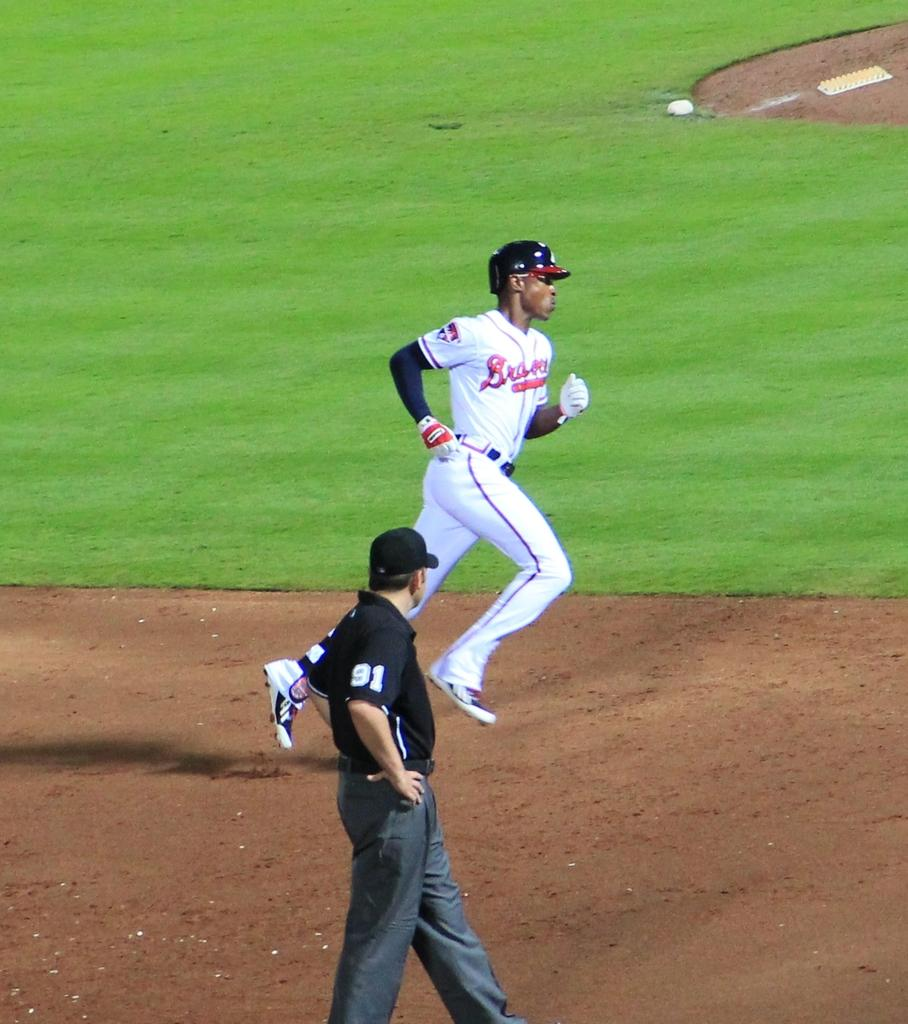<image>
Describe the image concisely. Baseball player wearing the name Braves on it running on the field. 